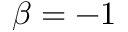Convert formula to latex. <formula><loc_0><loc_0><loc_500><loc_500>\beta = - 1</formula> 